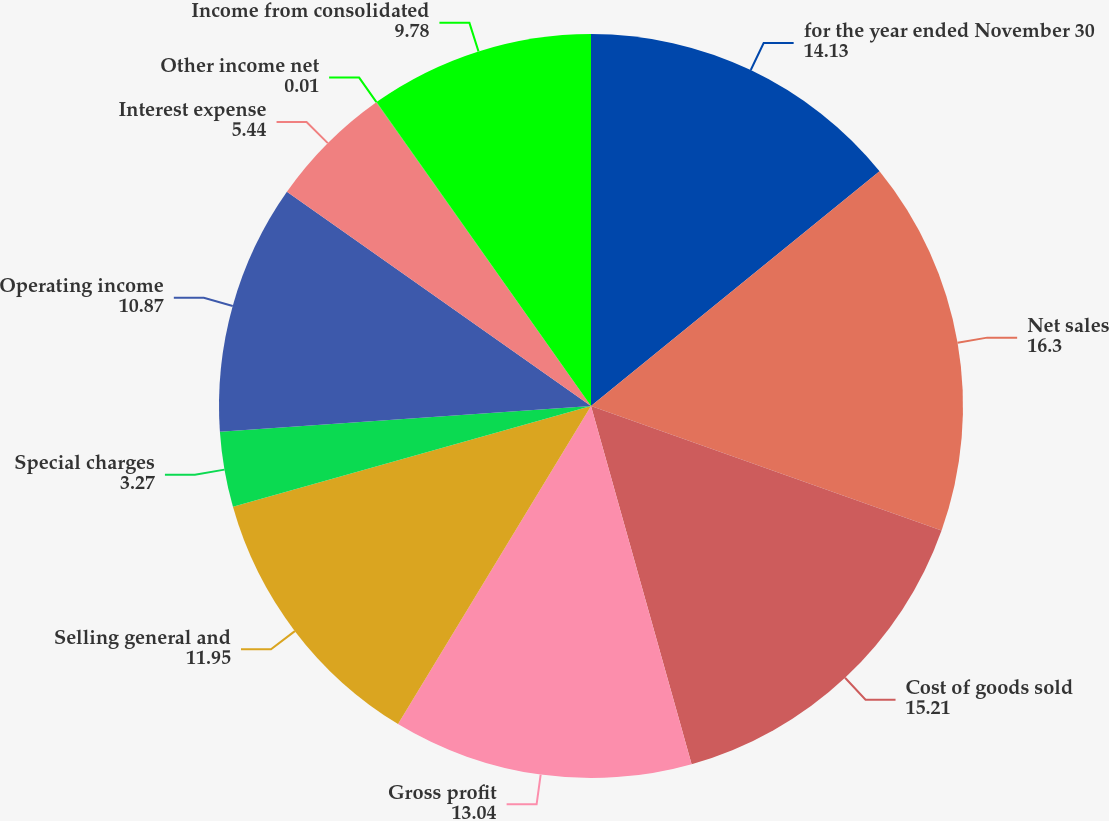Convert chart to OTSL. <chart><loc_0><loc_0><loc_500><loc_500><pie_chart><fcel>for the year ended November 30<fcel>Net sales<fcel>Cost of goods sold<fcel>Gross profit<fcel>Selling general and<fcel>Special charges<fcel>Operating income<fcel>Interest expense<fcel>Other income net<fcel>Income from consolidated<nl><fcel>14.13%<fcel>16.3%<fcel>15.21%<fcel>13.04%<fcel>11.95%<fcel>3.27%<fcel>10.87%<fcel>5.44%<fcel>0.01%<fcel>9.78%<nl></chart> 